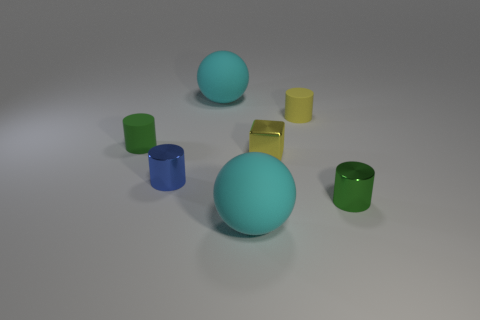Is the color of the small shiny block the same as the tiny rubber cylinder that is right of the tiny yellow block?
Provide a succinct answer. Yes. There is a rubber thing that is the same color as the small metallic cube; what is its shape?
Keep it short and to the point. Cylinder. There is a cyan matte ball that is behind the cyan ball that is in front of the green matte thing; what number of big matte balls are in front of it?
Offer a very short reply. 1. There is a tiny matte object on the left side of the tiny blue metal cylinder; what shape is it?
Make the answer very short. Cylinder. What number of other things are made of the same material as the block?
Provide a short and direct response. 2. Are there fewer large cyan objects in front of the small green shiny object than things that are in front of the yellow shiny cube?
Ensure brevity in your answer.  Yes. The other metallic object that is the same shape as the green metallic thing is what color?
Offer a very short reply. Blue. Do the metal cylinder left of the green shiny cylinder and the small green metal thing have the same size?
Ensure brevity in your answer.  Yes. Is the number of large matte things that are on the right side of the tiny green metallic cylinder less than the number of red cylinders?
Provide a succinct answer. No. What is the size of the cyan thing on the right side of the cyan ball behind the tiny yellow cylinder?
Make the answer very short. Large. 